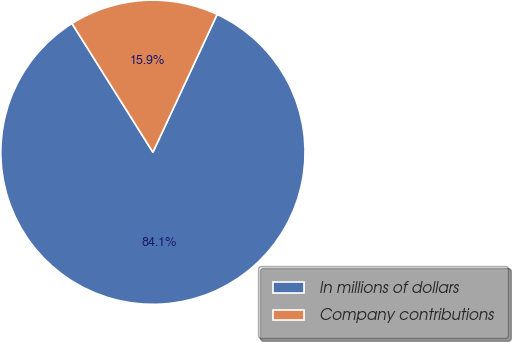<chart> <loc_0><loc_0><loc_500><loc_500><pie_chart><fcel>In millions of dollars<fcel>Company contributions<nl><fcel>84.13%<fcel>15.87%<nl></chart> 